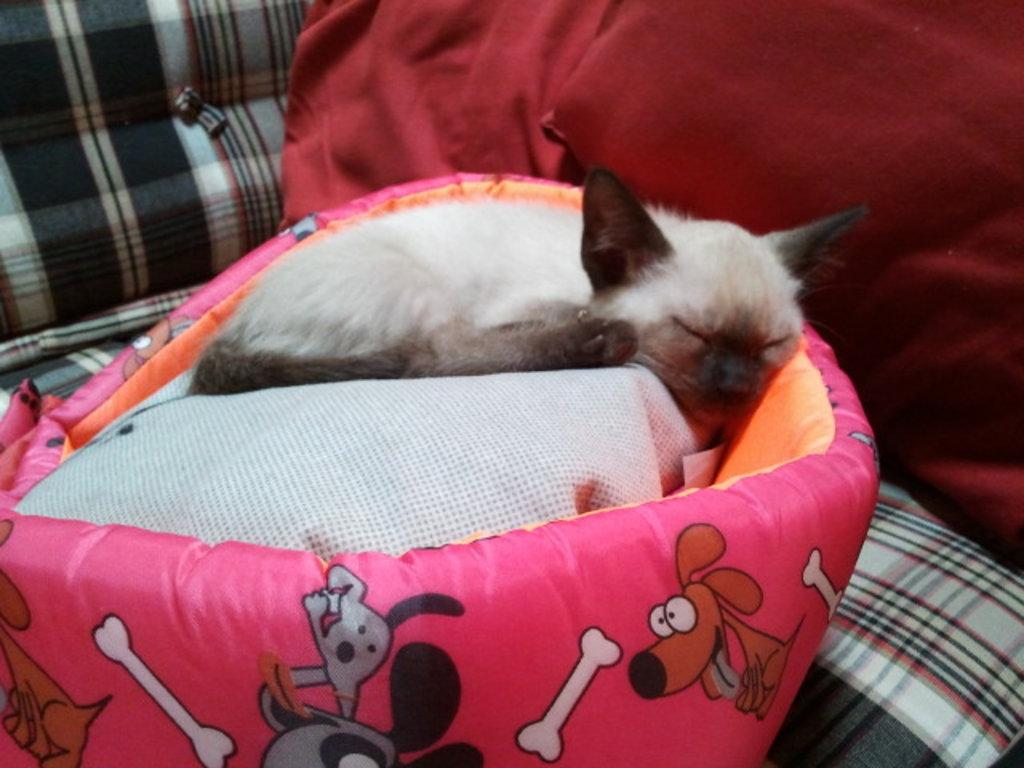What animal can be seen in the image? There is a cat in the image. What is the cat doing in the image? The cat is sleeping on a cat bed. Can you describe the red object in the image? There is a red object in the top right side of the image. What else can be seen in the background of the image? There appears to be a bed in the background of the image. How much dust can be seen on the spoon in the image? There is no spoon present in the image, so it is not possible to determine the amount of dust on it. 